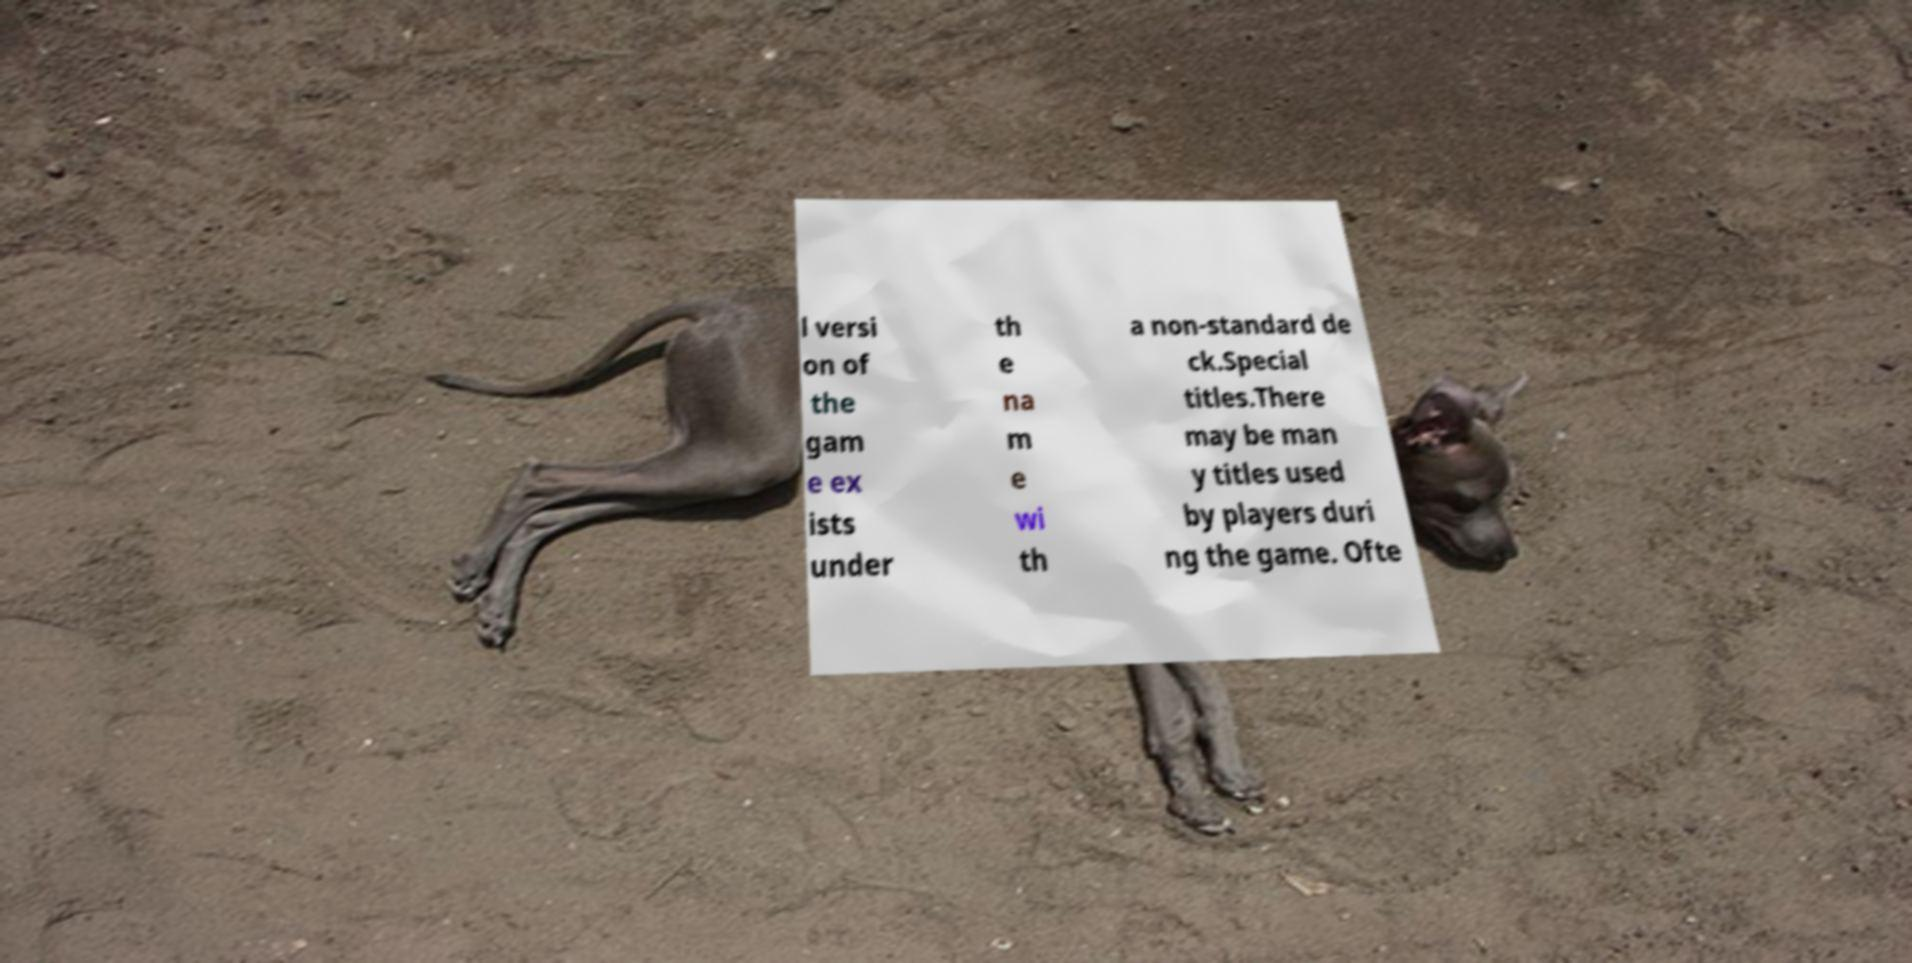There's text embedded in this image that I need extracted. Can you transcribe it verbatim? l versi on of the gam e ex ists under th e na m e wi th a non-standard de ck.Special titles.There may be man y titles used by players duri ng the game. Ofte 